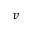<formula> <loc_0><loc_0><loc_500><loc_500>v</formula> 